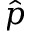Convert formula to latex. <formula><loc_0><loc_0><loc_500><loc_500>\hat { p }</formula> 